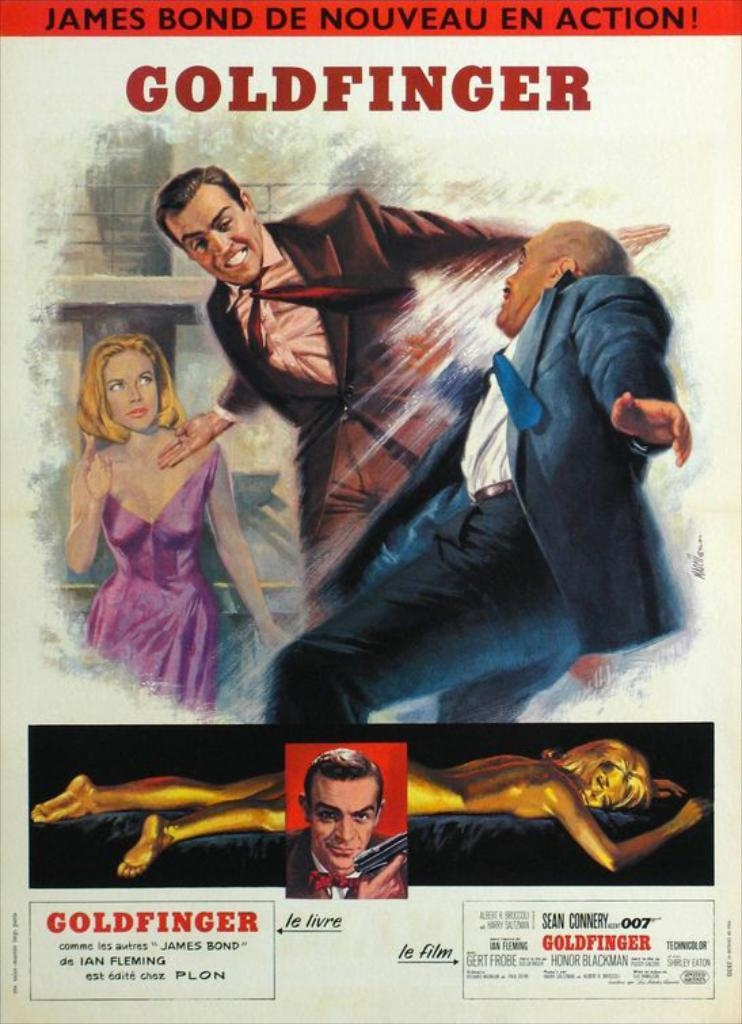<image>
Describe the image concisely. Goldginger movie poster shows Bond in a middle of action. 